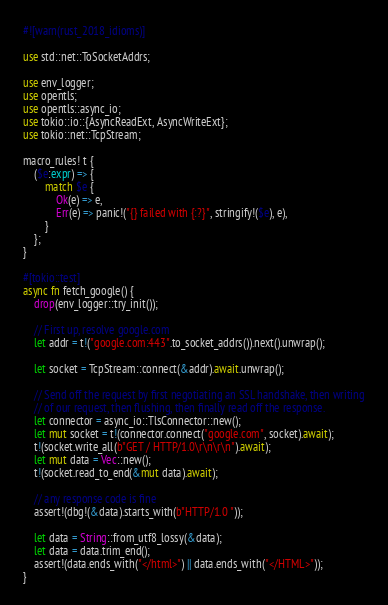<code> <loc_0><loc_0><loc_500><loc_500><_Rust_>#![warn(rust_2018_idioms)]

use std::net::ToSocketAddrs;

use env_logger;
use opentls;
use opentls::async_io;
use tokio::io::{AsyncReadExt, AsyncWriteExt};
use tokio::net::TcpStream;

macro_rules! t {
    ($e:expr) => {
        match $e {
            Ok(e) => e,
            Err(e) => panic!("{} failed with {:?}", stringify!($e), e),
        }
    };
}

#[tokio::test]
async fn fetch_google() {
    drop(env_logger::try_init());

    // First up, resolve google.com
    let addr = t!("google.com:443".to_socket_addrs()).next().unwrap();

    let socket = TcpStream::connect(&addr).await.unwrap();

    // Send off the request by first negotiating an SSL handshake, then writing
    // of our request, then flushing, then finally read off the response.
    let connector = async_io::TlsConnector::new();
    let mut socket = t!(connector.connect("google.com", socket).await);
    t!(socket.write_all(b"GET / HTTP/1.0\r\n\r\n").await);
    let mut data = Vec::new();
    t!(socket.read_to_end(&mut data).await);

    // any response code is fine
    assert!(dbg!(&data).starts_with(b"HTTP/1.0 "));

    let data = String::from_utf8_lossy(&data);
    let data = data.trim_end();
    assert!(data.ends_with("</html>") || data.ends_with("</HTML>"));
}
</code> 